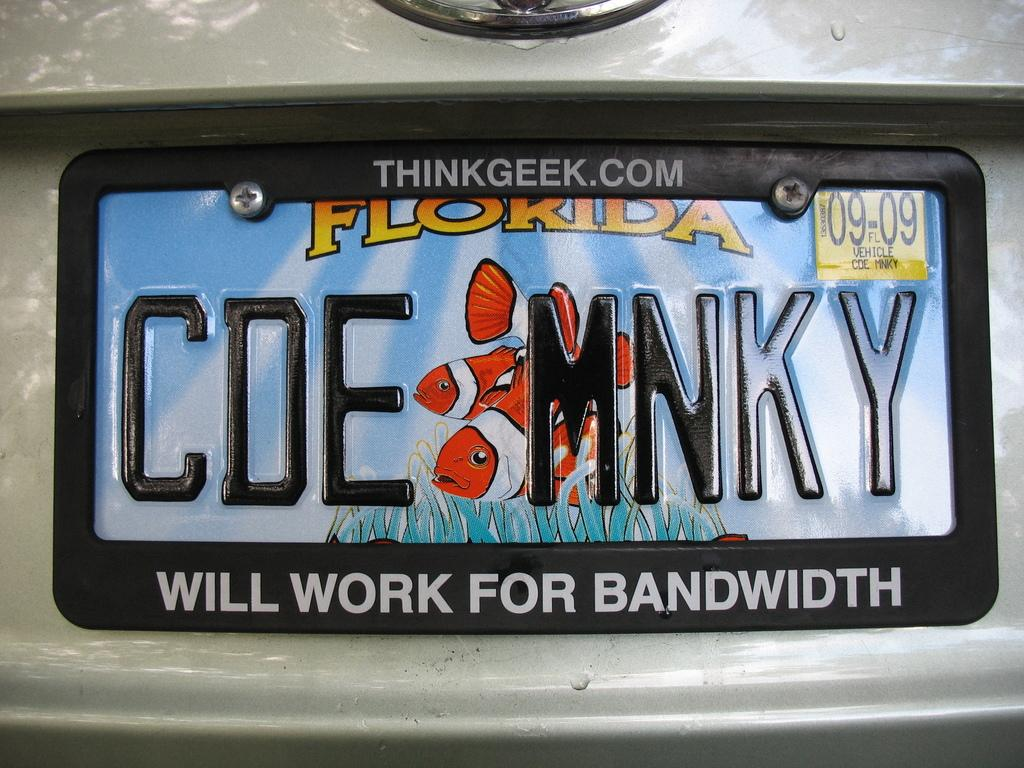<image>
Write a terse but informative summary of the picture. License Plate from Florida with the words CDE MNKY. 